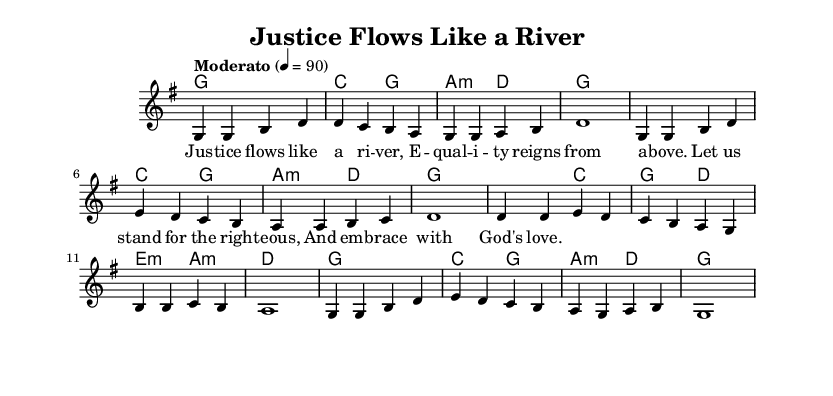What is the key signature of this music? The key signature is identified at the beginning of the staff, which shows one sharp indicating G major.
Answer: G major What is the time signature of this music? The time signature is located at the beginning of the piece, showing four beats per measure (4/4).
Answer: 4/4 What is the tempo marking of this song? The tempo marking is indicated on the score as "Moderato," with a metronome marking of 90 beats per minute.
Answer: Moderato 90 How many measures are in the melody section? By counting the measures in the melody line, we find there are 8 measures.
Answer: 8 What is the lyrical theme of this hymn? The lyrics reflect a theme of justice and equality, emphasizing standing for righteousness and embracing love.
Answer: Justice and equality What type of musical piece is "Justice Flows Like a River"? This piece is a gospel hymn, which is a type of religious music that often conveys themes of faith, justice, and community.
Answer: Gospel hymn Which chord appears most frequently in the harmonies? Upon reviewing the chord progression, the G major chord appears most frequently throughout the piece.
Answer: G major 